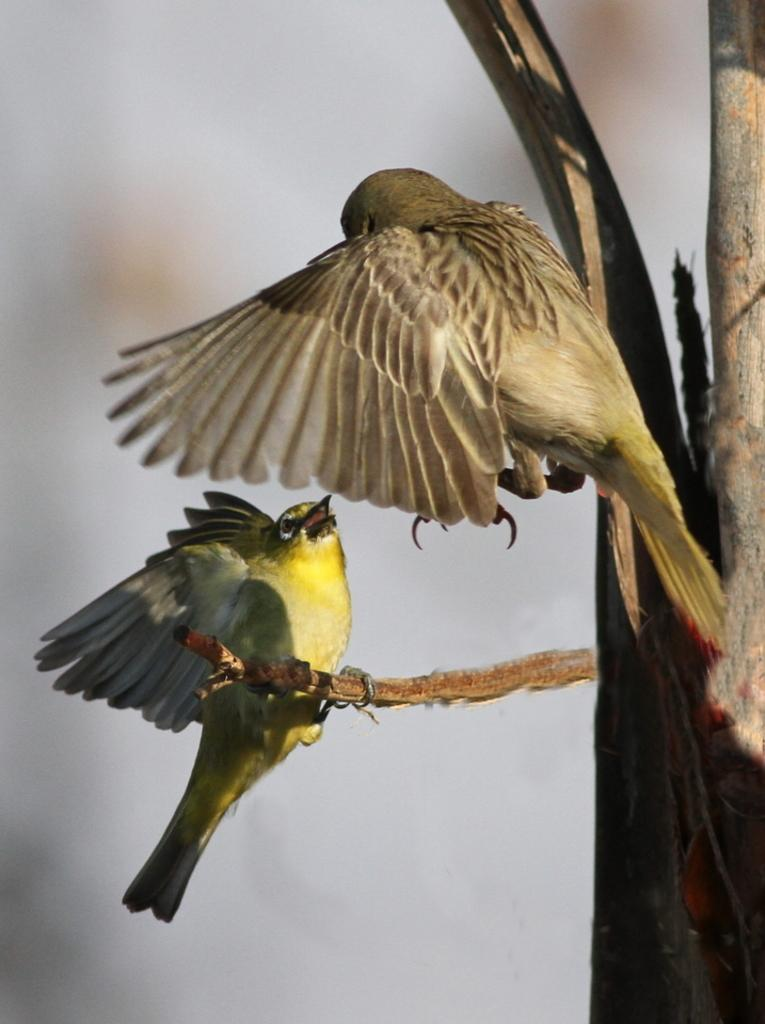What animals can be seen in the image? There are two birds in the image. Where are the birds located in the image? The birds are in the center of the image. What type of suit can be seen on the birds in the image? There are no suits present on the birds in the image; they are simply birds. 